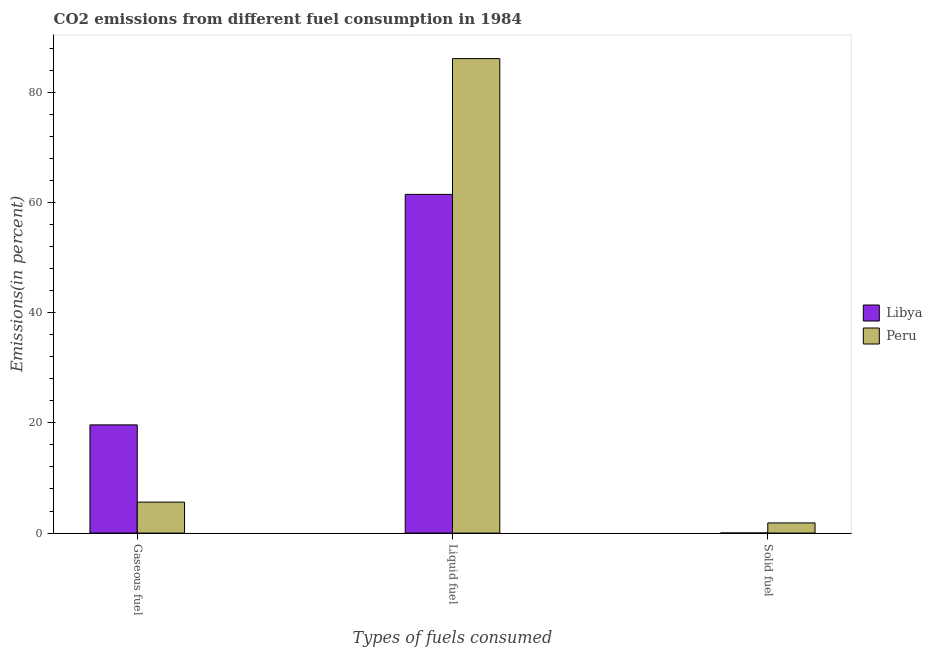How many different coloured bars are there?
Give a very brief answer. 2. How many groups of bars are there?
Keep it short and to the point. 3. Are the number of bars per tick equal to the number of legend labels?
Offer a very short reply. Yes. How many bars are there on the 2nd tick from the right?
Give a very brief answer. 2. What is the label of the 2nd group of bars from the left?
Provide a succinct answer. Liquid fuel. What is the percentage of gaseous fuel emission in Libya?
Your response must be concise. 19.64. Across all countries, what is the maximum percentage of liquid fuel emission?
Your response must be concise. 86.12. Across all countries, what is the minimum percentage of liquid fuel emission?
Your answer should be compact. 61.48. In which country was the percentage of liquid fuel emission maximum?
Make the answer very short. Peru. In which country was the percentage of solid fuel emission minimum?
Give a very brief answer. Libya. What is the total percentage of liquid fuel emission in the graph?
Offer a very short reply. 147.6. What is the difference between the percentage of gaseous fuel emission in Peru and that in Libya?
Your answer should be very brief. -14.02. What is the difference between the percentage of liquid fuel emission in Peru and the percentage of solid fuel emission in Libya?
Make the answer very short. 86.11. What is the average percentage of liquid fuel emission per country?
Keep it short and to the point. 73.8. What is the difference between the percentage of gaseous fuel emission and percentage of liquid fuel emission in Peru?
Your response must be concise. -80.51. What is the ratio of the percentage of liquid fuel emission in Libya to that in Peru?
Keep it short and to the point. 0.71. What is the difference between the highest and the second highest percentage of liquid fuel emission?
Your answer should be compact. 24.65. What is the difference between the highest and the lowest percentage of gaseous fuel emission?
Offer a very short reply. 14.02. What does the 1st bar from the left in Solid fuel represents?
Give a very brief answer. Libya. What does the 2nd bar from the right in Liquid fuel represents?
Offer a terse response. Libya. Is it the case that in every country, the sum of the percentage of gaseous fuel emission and percentage of liquid fuel emission is greater than the percentage of solid fuel emission?
Your answer should be very brief. Yes. How many bars are there?
Provide a short and direct response. 6. How many countries are there in the graph?
Your response must be concise. 2. Does the graph contain any zero values?
Ensure brevity in your answer.  No. Where does the legend appear in the graph?
Provide a succinct answer. Center right. How many legend labels are there?
Provide a succinct answer. 2. How are the legend labels stacked?
Your answer should be compact. Vertical. What is the title of the graph?
Keep it short and to the point. CO2 emissions from different fuel consumption in 1984. What is the label or title of the X-axis?
Provide a short and direct response. Types of fuels consumed. What is the label or title of the Y-axis?
Make the answer very short. Emissions(in percent). What is the Emissions(in percent) in Libya in Gaseous fuel?
Your answer should be very brief. 19.64. What is the Emissions(in percent) in Peru in Gaseous fuel?
Provide a short and direct response. 5.62. What is the Emissions(in percent) of Libya in Liquid fuel?
Provide a short and direct response. 61.48. What is the Emissions(in percent) of Peru in Liquid fuel?
Your response must be concise. 86.12. What is the Emissions(in percent) of Libya in Solid fuel?
Give a very brief answer. 0.01. What is the Emissions(in percent) in Peru in Solid fuel?
Keep it short and to the point. 1.84. Across all Types of fuels consumed, what is the maximum Emissions(in percent) in Libya?
Provide a short and direct response. 61.48. Across all Types of fuels consumed, what is the maximum Emissions(in percent) of Peru?
Offer a terse response. 86.12. Across all Types of fuels consumed, what is the minimum Emissions(in percent) of Libya?
Give a very brief answer. 0.01. Across all Types of fuels consumed, what is the minimum Emissions(in percent) of Peru?
Your answer should be compact. 1.84. What is the total Emissions(in percent) of Libya in the graph?
Your answer should be compact. 81.13. What is the total Emissions(in percent) in Peru in the graph?
Your answer should be very brief. 93.58. What is the difference between the Emissions(in percent) of Libya in Gaseous fuel and that in Liquid fuel?
Provide a short and direct response. -41.84. What is the difference between the Emissions(in percent) in Peru in Gaseous fuel and that in Liquid fuel?
Provide a short and direct response. -80.51. What is the difference between the Emissions(in percent) of Libya in Gaseous fuel and that in Solid fuel?
Provide a short and direct response. 19.63. What is the difference between the Emissions(in percent) in Peru in Gaseous fuel and that in Solid fuel?
Offer a terse response. 3.77. What is the difference between the Emissions(in percent) in Libya in Liquid fuel and that in Solid fuel?
Give a very brief answer. 61.47. What is the difference between the Emissions(in percent) of Peru in Liquid fuel and that in Solid fuel?
Keep it short and to the point. 84.28. What is the difference between the Emissions(in percent) in Libya in Gaseous fuel and the Emissions(in percent) in Peru in Liquid fuel?
Offer a terse response. -66.49. What is the difference between the Emissions(in percent) in Libya in Gaseous fuel and the Emissions(in percent) in Peru in Solid fuel?
Your response must be concise. 17.8. What is the difference between the Emissions(in percent) in Libya in Liquid fuel and the Emissions(in percent) in Peru in Solid fuel?
Keep it short and to the point. 59.64. What is the average Emissions(in percent) of Libya per Types of fuels consumed?
Give a very brief answer. 27.04. What is the average Emissions(in percent) of Peru per Types of fuels consumed?
Provide a short and direct response. 31.2. What is the difference between the Emissions(in percent) of Libya and Emissions(in percent) of Peru in Gaseous fuel?
Make the answer very short. 14.02. What is the difference between the Emissions(in percent) of Libya and Emissions(in percent) of Peru in Liquid fuel?
Your response must be concise. -24.65. What is the difference between the Emissions(in percent) of Libya and Emissions(in percent) of Peru in Solid fuel?
Keep it short and to the point. -1.83. What is the ratio of the Emissions(in percent) of Libya in Gaseous fuel to that in Liquid fuel?
Your answer should be very brief. 0.32. What is the ratio of the Emissions(in percent) of Peru in Gaseous fuel to that in Liquid fuel?
Give a very brief answer. 0.07. What is the ratio of the Emissions(in percent) in Libya in Gaseous fuel to that in Solid fuel?
Provide a succinct answer. 1533. What is the ratio of the Emissions(in percent) of Peru in Gaseous fuel to that in Solid fuel?
Your answer should be very brief. 3.05. What is the ratio of the Emissions(in percent) in Libya in Liquid fuel to that in Solid fuel?
Your answer should be very brief. 4799. What is the ratio of the Emissions(in percent) of Peru in Liquid fuel to that in Solid fuel?
Provide a succinct answer. 46.73. What is the difference between the highest and the second highest Emissions(in percent) in Libya?
Your answer should be very brief. 41.84. What is the difference between the highest and the second highest Emissions(in percent) of Peru?
Keep it short and to the point. 80.51. What is the difference between the highest and the lowest Emissions(in percent) of Libya?
Your answer should be very brief. 61.47. What is the difference between the highest and the lowest Emissions(in percent) of Peru?
Give a very brief answer. 84.28. 